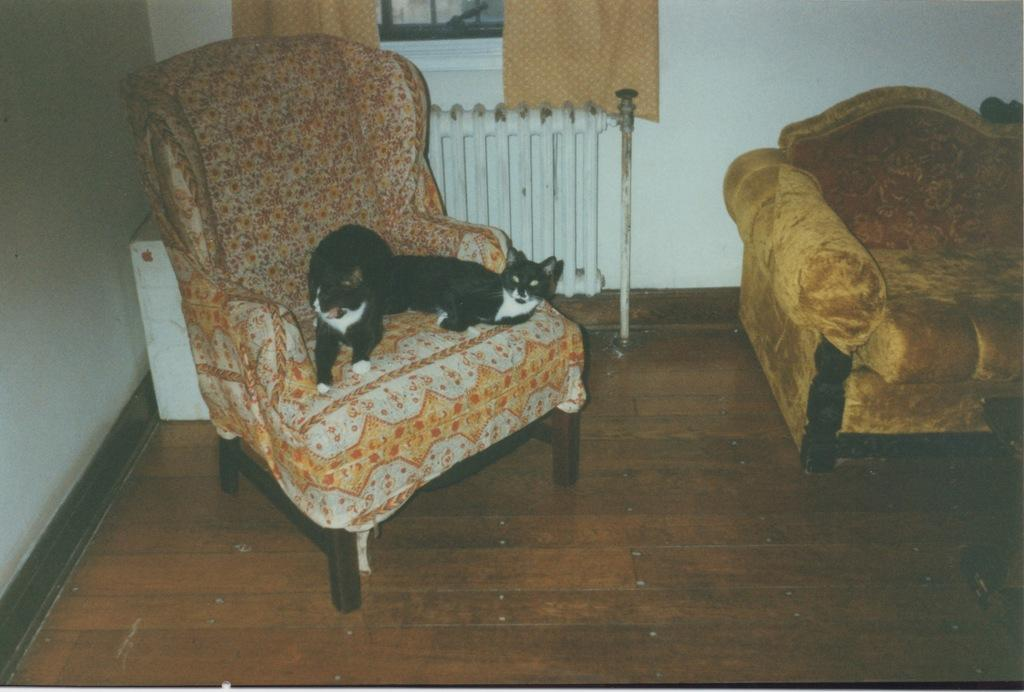What type of animal is on the sofa chair in the image? There is a dog on the sofa chair in the image. What can be seen on the left side of the image? There is a wall on the left side of the image. Where is the sand located in the image? There is no sand present in the image. What type of crown is the dog wearing in the image? The dog is not wearing a crown in the image; it is not present. 